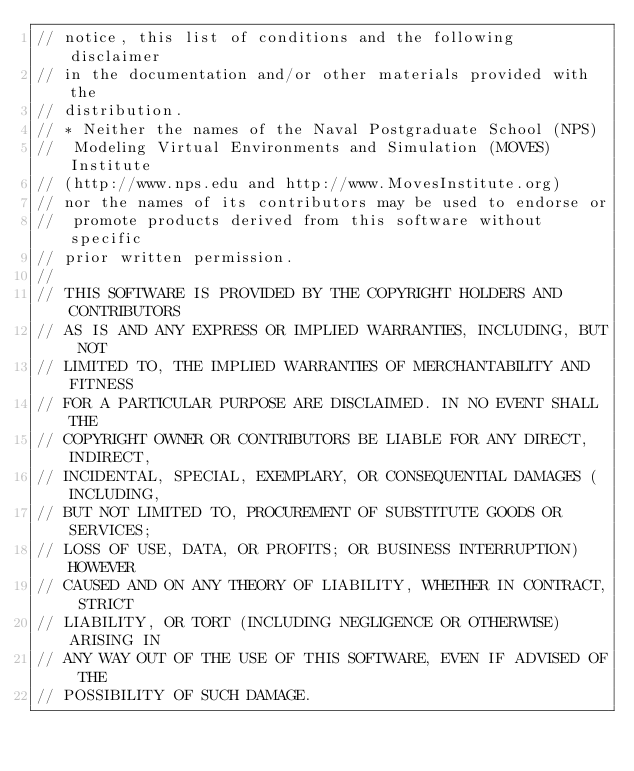<code> <loc_0><loc_0><loc_500><loc_500><_C_>// notice, this list of conditions and the following disclaimer
// in the documentation and/or other materials provided with the
// distribution.
// * Neither the names of the Naval Postgraduate School (NPS)
//  Modeling Virtual Environments and Simulation (MOVES) Institute
// (http://www.nps.edu and http://www.MovesInstitute.org)
// nor the names of its contributors may be used to endorse or
//  promote products derived from this software without specific
// prior written permission.
// 
// THIS SOFTWARE IS PROVIDED BY THE COPYRIGHT HOLDERS AND CONTRIBUTORS
// AS IS AND ANY EXPRESS OR IMPLIED WARRANTIES, INCLUDING, BUT NOT
// LIMITED TO, THE IMPLIED WARRANTIES OF MERCHANTABILITY AND FITNESS
// FOR A PARTICULAR PURPOSE ARE DISCLAIMED. IN NO EVENT SHALL THE
// COPYRIGHT OWNER OR CONTRIBUTORS BE LIABLE FOR ANY DIRECT, INDIRECT,
// INCIDENTAL, SPECIAL, EXEMPLARY, OR CONSEQUENTIAL DAMAGES (INCLUDING,
// BUT NOT LIMITED TO, PROCUREMENT OF SUBSTITUTE GOODS OR SERVICES;
// LOSS OF USE, DATA, OR PROFITS; OR BUSINESS INTERRUPTION) HOWEVER
// CAUSED AND ON ANY THEORY OF LIABILITY, WHETHER IN CONTRACT, STRICT
// LIABILITY, OR TORT (INCLUDING NEGLIGENCE OR OTHERWISE) ARISING IN
// ANY WAY OUT OF THE USE OF THIS SOFTWARE, EVEN IF ADVISED OF THE
// POSSIBILITY OF SUCH DAMAGE.
</code> 